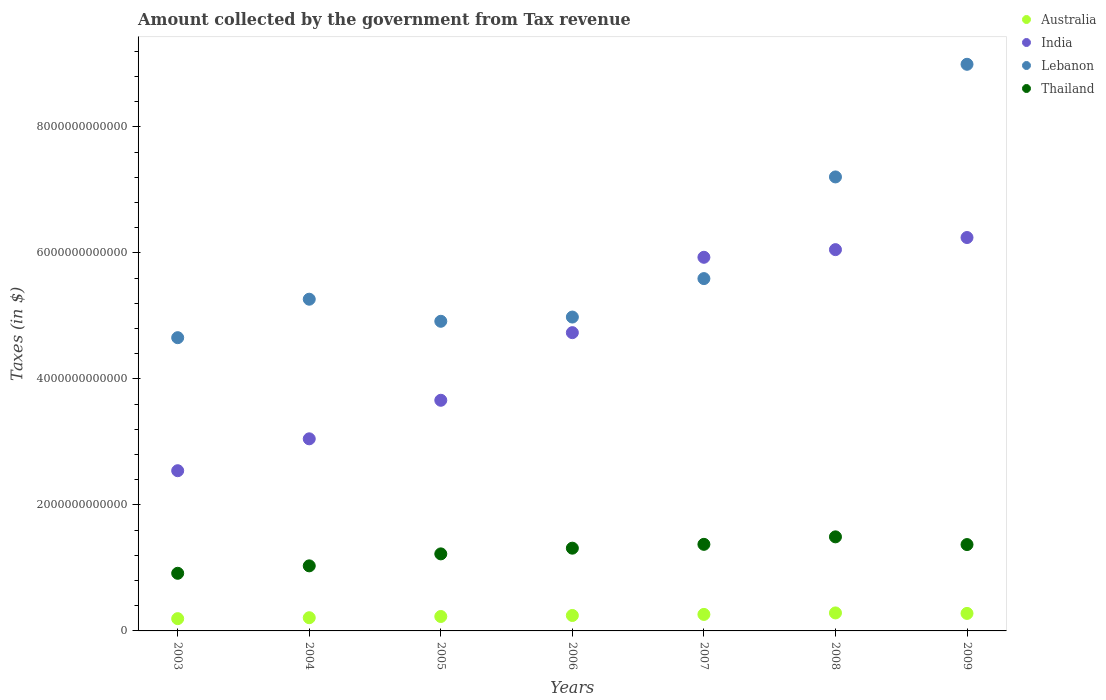How many different coloured dotlines are there?
Provide a succinct answer. 4. What is the amount collected by the government from tax revenue in Australia in 2006?
Give a very brief answer. 2.45e+11. Across all years, what is the maximum amount collected by the government from tax revenue in India?
Your answer should be very brief. 6.25e+12. Across all years, what is the minimum amount collected by the government from tax revenue in Lebanon?
Your answer should be compact. 4.66e+12. In which year was the amount collected by the government from tax revenue in Lebanon maximum?
Make the answer very short. 2009. What is the total amount collected by the government from tax revenue in Thailand in the graph?
Offer a very short reply. 8.72e+12. What is the difference between the amount collected by the government from tax revenue in Thailand in 2006 and that in 2009?
Ensure brevity in your answer.  -5.74e+1. What is the difference between the amount collected by the government from tax revenue in Australia in 2006 and the amount collected by the government from tax revenue in Lebanon in 2003?
Keep it short and to the point. -4.41e+12. What is the average amount collected by the government from tax revenue in Lebanon per year?
Offer a very short reply. 5.95e+12. In the year 2005, what is the difference between the amount collected by the government from tax revenue in India and amount collected by the government from tax revenue in Lebanon?
Give a very brief answer. -1.25e+12. In how many years, is the amount collected by the government from tax revenue in Lebanon greater than 4000000000000 $?
Your answer should be compact. 7. What is the ratio of the amount collected by the government from tax revenue in India in 2006 to that in 2007?
Your answer should be very brief. 0.8. Is the difference between the amount collected by the government from tax revenue in India in 2006 and 2007 greater than the difference between the amount collected by the government from tax revenue in Lebanon in 2006 and 2007?
Offer a very short reply. No. What is the difference between the highest and the second highest amount collected by the government from tax revenue in Australia?
Give a very brief answer. 7.66e+09. What is the difference between the highest and the lowest amount collected by the government from tax revenue in Australia?
Your answer should be compact. 9.08e+1. In how many years, is the amount collected by the government from tax revenue in India greater than the average amount collected by the government from tax revenue in India taken over all years?
Your answer should be compact. 4. Is it the case that in every year, the sum of the amount collected by the government from tax revenue in India and amount collected by the government from tax revenue in Thailand  is greater than the sum of amount collected by the government from tax revenue in Lebanon and amount collected by the government from tax revenue in Australia?
Your answer should be very brief. No. Does the amount collected by the government from tax revenue in Australia monotonically increase over the years?
Your answer should be compact. No. Is the amount collected by the government from tax revenue in Thailand strictly less than the amount collected by the government from tax revenue in Australia over the years?
Ensure brevity in your answer.  No. How many dotlines are there?
Keep it short and to the point. 4. How many years are there in the graph?
Make the answer very short. 7. What is the difference between two consecutive major ticks on the Y-axis?
Provide a short and direct response. 2.00e+12. Are the values on the major ticks of Y-axis written in scientific E-notation?
Offer a terse response. No. Does the graph contain grids?
Provide a succinct answer. No. What is the title of the graph?
Ensure brevity in your answer.  Amount collected by the government from Tax revenue. What is the label or title of the X-axis?
Make the answer very short. Years. What is the label or title of the Y-axis?
Provide a succinct answer. Taxes (in $). What is the Taxes (in $) of Australia in 2003?
Ensure brevity in your answer.  1.95e+11. What is the Taxes (in $) in India in 2003?
Your answer should be compact. 2.54e+12. What is the Taxes (in $) of Lebanon in 2003?
Give a very brief answer. 4.66e+12. What is the Taxes (in $) in Thailand in 2003?
Your response must be concise. 9.15e+11. What is the Taxes (in $) in Australia in 2004?
Provide a succinct answer. 2.10e+11. What is the Taxes (in $) in India in 2004?
Your answer should be compact. 3.05e+12. What is the Taxes (in $) of Lebanon in 2004?
Ensure brevity in your answer.  5.27e+12. What is the Taxes (in $) in Thailand in 2004?
Provide a succinct answer. 1.03e+12. What is the Taxes (in $) in Australia in 2005?
Provide a short and direct response. 2.29e+11. What is the Taxes (in $) of India in 2005?
Provide a short and direct response. 3.66e+12. What is the Taxes (in $) in Lebanon in 2005?
Give a very brief answer. 4.92e+12. What is the Taxes (in $) in Thailand in 2005?
Your answer should be very brief. 1.22e+12. What is the Taxes (in $) of Australia in 2006?
Your response must be concise. 2.45e+11. What is the Taxes (in $) of India in 2006?
Offer a very short reply. 4.74e+12. What is the Taxes (in $) of Lebanon in 2006?
Your answer should be compact. 4.98e+12. What is the Taxes (in $) in Thailand in 2006?
Provide a short and direct response. 1.31e+12. What is the Taxes (in $) of Australia in 2007?
Make the answer very short. 2.62e+11. What is the Taxes (in $) in India in 2007?
Ensure brevity in your answer.  5.93e+12. What is the Taxes (in $) in Lebanon in 2007?
Make the answer very short. 5.59e+12. What is the Taxes (in $) of Thailand in 2007?
Make the answer very short. 1.37e+12. What is the Taxes (in $) in Australia in 2008?
Offer a very short reply. 2.86e+11. What is the Taxes (in $) in India in 2008?
Your answer should be very brief. 6.05e+12. What is the Taxes (in $) in Lebanon in 2008?
Ensure brevity in your answer.  7.21e+12. What is the Taxes (in $) in Thailand in 2008?
Provide a succinct answer. 1.49e+12. What is the Taxes (in $) in Australia in 2009?
Your answer should be compact. 2.78e+11. What is the Taxes (in $) in India in 2009?
Make the answer very short. 6.25e+12. What is the Taxes (in $) of Lebanon in 2009?
Provide a succinct answer. 9.00e+12. What is the Taxes (in $) of Thailand in 2009?
Make the answer very short. 1.37e+12. Across all years, what is the maximum Taxes (in $) in Australia?
Keep it short and to the point. 2.86e+11. Across all years, what is the maximum Taxes (in $) of India?
Your response must be concise. 6.25e+12. Across all years, what is the maximum Taxes (in $) in Lebanon?
Your answer should be very brief. 9.00e+12. Across all years, what is the maximum Taxes (in $) in Thailand?
Your answer should be compact. 1.49e+12. Across all years, what is the minimum Taxes (in $) in Australia?
Offer a very short reply. 1.95e+11. Across all years, what is the minimum Taxes (in $) of India?
Provide a succinct answer. 2.54e+12. Across all years, what is the minimum Taxes (in $) of Lebanon?
Your answer should be compact. 4.66e+12. Across all years, what is the minimum Taxes (in $) of Thailand?
Give a very brief answer. 9.15e+11. What is the total Taxes (in $) of Australia in the graph?
Give a very brief answer. 1.70e+12. What is the total Taxes (in $) in India in the graph?
Offer a very short reply. 3.22e+13. What is the total Taxes (in $) in Lebanon in the graph?
Offer a very short reply. 4.16e+13. What is the total Taxes (in $) in Thailand in the graph?
Your answer should be compact. 8.72e+12. What is the difference between the Taxes (in $) of Australia in 2003 and that in 2004?
Offer a very short reply. -1.47e+1. What is the difference between the Taxes (in $) in India in 2003 and that in 2004?
Offer a very short reply. -5.06e+11. What is the difference between the Taxes (in $) of Lebanon in 2003 and that in 2004?
Your answer should be compact. -6.11e+11. What is the difference between the Taxes (in $) of Thailand in 2003 and that in 2004?
Your answer should be very brief. -1.18e+11. What is the difference between the Taxes (in $) of Australia in 2003 and that in 2005?
Give a very brief answer. -3.43e+1. What is the difference between the Taxes (in $) of India in 2003 and that in 2005?
Provide a short and direct response. -1.12e+12. What is the difference between the Taxes (in $) in Lebanon in 2003 and that in 2005?
Ensure brevity in your answer.  -2.60e+11. What is the difference between the Taxes (in $) in Thailand in 2003 and that in 2005?
Keep it short and to the point. -3.08e+11. What is the difference between the Taxes (in $) of Australia in 2003 and that in 2006?
Offer a terse response. -5.04e+1. What is the difference between the Taxes (in $) of India in 2003 and that in 2006?
Make the answer very short. -2.19e+12. What is the difference between the Taxes (in $) of Lebanon in 2003 and that in 2006?
Provide a short and direct response. -3.27e+11. What is the difference between the Taxes (in $) of Thailand in 2003 and that in 2006?
Make the answer very short. -3.99e+11. What is the difference between the Taxes (in $) in Australia in 2003 and that in 2007?
Offer a terse response. -6.72e+1. What is the difference between the Taxes (in $) in India in 2003 and that in 2007?
Offer a terse response. -3.39e+12. What is the difference between the Taxes (in $) in Lebanon in 2003 and that in 2007?
Your answer should be very brief. -9.38e+11. What is the difference between the Taxes (in $) in Thailand in 2003 and that in 2007?
Ensure brevity in your answer.  -4.60e+11. What is the difference between the Taxes (in $) of Australia in 2003 and that in 2008?
Your answer should be very brief. -9.08e+1. What is the difference between the Taxes (in $) of India in 2003 and that in 2008?
Provide a succinct answer. -3.51e+12. What is the difference between the Taxes (in $) in Lebanon in 2003 and that in 2008?
Offer a terse response. -2.55e+12. What is the difference between the Taxes (in $) in Thailand in 2003 and that in 2008?
Make the answer very short. -5.79e+11. What is the difference between the Taxes (in $) of Australia in 2003 and that in 2009?
Keep it short and to the point. -8.32e+1. What is the difference between the Taxes (in $) in India in 2003 and that in 2009?
Keep it short and to the point. -3.70e+12. What is the difference between the Taxes (in $) of Lebanon in 2003 and that in 2009?
Offer a very short reply. -4.34e+12. What is the difference between the Taxes (in $) in Thailand in 2003 and that in 2009?
Provide a succinct answer. -4.56e+11. What is the difference between the Taxes (in $) of Australia in 2004 and that in 2005?
Make the answer very short. -1.96e+1. What is the difference between the Taxes (in $) in India in 2004 and that in 2005?
Ensure brevity in your answer.  -6.12e+11. What is the difference between the Taxes (in $) in Lebanon in 2004 and that in 2005?
Your answer should be compact. 3.50e+11. What is the difference between the Taxes (in $) of Thailand in 2004 and that in 2005?
Keep it short and to the point. -1.90e+11. What is the difference between the Taxes (in $) in Australia in 2004 and that in 2006?
Your answer should be compact. -3.57e+1. What is the difference between the Taxes (in $) of India in 2004 and that in 2006?
Your response must be concise. -1.69e+12. What is the difference between the Taxes (in $) in Lebanon in 2004 and that in 2006?
Offer a very short reply. 2.83e+11. What is the difference between the Taxes (in $) in Thailand in 2004 and that in 2006?
Keep it short and to the point. -2.81e+11. What is the difference between the Taxes (in $) of Australia in 2004 and that in 2007?
Your answer should be compact. -5.24e+1. What is the difference between the Taxes (in $) of India in 2004 and that in 2007?
Your answer should be compact. -2.88e+12. What is the difference between the Taxes (in $) of Lebanon in 2004 and that in 2007?
Your answer should be very brief. -3.27e+11. What is the difference between the Taxes (in $) of Thailand in 2004 and that in 2007?
Keep it short and to the point. -3.41e+11. What is the difference between the Taxes (in $) in Australia in 2004 and that in 2008?
Give a very brief answer. -7.61e+1. What is the difference between the Taxes (in $) of India in 2004 and that in 2008?
Provide a short and direct response. -3.00e+12. What is the difference between the Taxes (in $) of Lebanon in 2004 and that in 2008?
Keep it short and to the point. -1.94e+12. What is the difference between the Taxes (in $) in Thailand in 2004 and that in 2008?
Your answer should be very brief. -4.60e+11. What is the difference between the Taxes (in $) of Australia in 2004 and that in 2009?
Offer a very short reply. -6.84e+1. What is the difference between the Taxes (in $) in India in 2004 and that in 2009?
Ensure brevity in your answer.  -3.20e+12. What is the difference between the Taxes (in $) in Lebanon in 2004 and that in 2009?
Your answer should be very brief. -3.73e+12. What is the difference between the Taxes (in $) of Thailand in 2004 and that in 2009?
Provide a short and direct response. -3.38e+11. What is the difference between the Taxes (in $) in Australia in 2005 and that in 2006?
Ensure brevity in your answer.  -1.61e+1. What is the difference between the Taxes (in $) of India in 2005 and that in 2006?
Offer a terse response. -1.07e+12. What is the difference between the Taxes (in $) of Lebanon in 2005 and that in 2006?
Your response must be concise. -6.71e+1. What is the difference between the Taxes (in $) of Thailand in 2005 and that in 2006?
Make the answer very short. -9.06e+1. What is the difference between the Taxes (in $) in Australia in 2005 and that in 2007?
Provide a succinct answer. -3.29e+1. What is the difference between the Taxes (in $) in India in 2005 and that in 2007?
Your response must be concise. -2.27e+12. What is the difference between the Taxes (in $) of Lebanon in 2005 and that in 2007?
Provide a short and direct response. -6.78e+11. What is the difference between the Taxes (in $) in Thailand in 2005 and that in 2007?
Your answer should be compact. -1.51e+11. What is the difference between the Taxes (in $) of Australia in 2005 and that in 2008?
Keep it short and to the point. -5.65e+1. What is the difference between the Taxes (in $) in India in 2005 and that in 2008?
Provide a short and direct response. -2.39e+12. What is the difference between the Taxes (in $) in Lebanon in 2005 and that in 2008?
Keep it short and to the point. -2.29e+12. What is the difference between the Taxes (in $) in Thailand in 2005 and that in 2008?
Offer a terse response. -2.70e+11. What is the difference between the Taxes (in $) in Australia in 2005 and that in 2009?
Give a very brief answer. -4.89e+1. What is the difference between the Taxes (in $) in India in 2005 and that in 2009?
Your answer should be compact. -2.58e+12. What is the difference between the Taxes (in $) in Lebanon in 2005 and that in 2009?
Ensure brevity in your answer.  -4.08e+12. What is the difference between the Taxes (in $) in Thailand in 2005 and that in 2009?
Your answer should be very brief. -1.48e+11. What is the difference between the Taxes (in $) in Australia in 2006 and that in 2007?
Give a very brief answer. -1.68e+1. What is the difference between the Taxes (in $) of India in 2006 and that in 2007?
Keep it short and to the point. -1.20e+12. What is the difference between the Taxes (in $) in Lebanon in 2006 and that in 2007?
Make the answer very short. -6.11e+11. What is the difference between the Taxes (in $) of Thailand in 2006 and that in 2007?
Offer a terse response. -6.08e+1. What is the difference between the Taxes (in $) of Australia in 2006 and that in 2008?
Provide a succinct answer. -4.04e+1. What is the difference between the Taxes (in $) of India in 2006 and that in 2008?
Your answer should be very brief. -1.32e+12. What is the difference between the Taxes (in $) of Lebanon in 2006 and that in 2008?
Offer a very short reply. -2.22e+12. What is the difference between the Taxes (in $) in Thailand in 2006 and that in 2008?
Offer a terse response. -1.80e+11. What is the difference between the Taxes (in $) in Australia in 2006 and that in 2009?
Your answer should be compact. -3.28e+1. What is the difference between the Taxes (in $) in India in 2006 and that in 2009?
Offer a very short reply. -1.51e+12. What is the difference between the Taxes (in $) of Lebanon in 2006 and that in 2009?
Provide a succinct answer. -4.01e+12. What is the difference between the Taxes (in $) in Thailand in 2006 and that in 2009?
Your response must be concise. -5.74e+1. What is the difference between the Taxes (in $) of Australia in 2007 and that in 2008?
Your response must be concise. -2.37e+1. What is the difference between the Taxes (in $) of India in 2007 and that in 2008?
Your answer should be very brief. -1.22e+11. What is the difference between the Taxes (in $) of Lebanon in 2007 and that in 2008?
Make the answer very short. -1.61e+12. What is the difference between the Taxes (in $) in Thailand in 2007 and that in 2008?
Ensure brevity in your answer.  -1.19e+11. What is the difference between the Taxes (in $) in Australia in 2007 and that in 2009?
Your response must be concise. -1.60e+1. What is the difference between the Taxes (in $) of India in 2007 and that in 2009?
Your answer should be very brief. -3.14e+11. What is the difference between the Taxes (in $) of Lebanon in 2007 and that in 2009?
Offer a very short reply. -3.40e+12. What is the difference between the Taxes (in $) in Thailand in 2007 and that in 2009?
Offer a terse response. 3.46e+09. What is the difference between the Taxes (in $) of Australia in 2008 and that in 2009?
Provide a succinct answer. 7.66e+09. What is the difference between the Taxes (in $) in India in 2008 and that in 2009?
Give a very brief answer. -1.92e+11. What is the difference between the Taxes (in $) in Lebanon in 2008 and that in 2009?
Keep it short and to the point. -1.79e+12. What is the difference between the Taxes (in $) in Thailand in 2008 and that in 2009?
Offer a very short reply. 1.22e+11. What is the difference between the Taxes (in $) of Australia in 2003 and the Taxes (in $) of India in 2004?
Provide a succinct answer. -2.85e+12. What is the difference between the Taxes (in $) of Australia in 2003 and the Taxes (in $) of Lebanon in 2004?
Your response must be concise. -5.07e+12. What is the difference between the Taxes (in $) of Australia in 2003 and the Taxes (in $) of Thailand in 2004?
Make the answer very short. -8.38e+11. What is the difference between the Taxes (in $) in India in 2003 and the Taxes (in $) in Lebanon in 2004?
Provide a short and direct response. -2.72e+12. What is the difference between the Taxes (in $) of India in 2003 and the Taxes (in $) of Thailand in 2004?
Your response must be concise. 1.51e+12. What is the difference between the Taxes (in $) of Lebanon in 2003 and the Taxes (in $) of Thailand in 2004?
Make the answer very short. 3.62e+12. What is the difference between the Taxes (in $) in Australia in 2003 and the Taxes (in $) in India in 2005?
Keep it short and to the point. -3.47e+12. What is the difference between the Taxes (in $) in Australia in 2003 and the Taxes (in $) in Lebanon in 2005?
Your answer should be very brief. -4.72e+12. What is the difference between the Taxes (in $) of Australia in 2003 and the Taxes (in $) of Thailand in 2005?
Your response must be concise. -1.03e+12. What is the difference between the Taxes (in $) in India in 2003 and the Taxes (in $) in Lebanon in 2005?
Your answer should be very brief. -2.37e+12. What is the difference between the Taxes (in $) of India in 2003 and the Taxes (in $) of Thailand in 2005?
Give a very brief answer. 1.32e+12. What is the difference between the Taxes (in $) of Lebanon in 2003 and the Taxes (in $) of Thailand in 2005?
Your answer should be very brief. 3.43e+12. What is the difference between the Taxes (in $) in Australia in 2003 and the Taxes (in $) in India in 2006?
Ensure brevity in your answer.  -4.54e+12. What is the difference between the Taxes (in $) in Australia in 2003 and the Taxes (in $) in Lebanon in 2006?
Keep it short and to the point. -4.79e+12. What is the difference between the Taxes (in $) in Australia in 2003 and the Taxes (in $) in Thailand in 2006?
Provide a succinct answer. -1.12e+12. What is the difference between the Taxes (in $) in India in 2003 and the Taxes (in $) in Lebanon in 2006?
Offer a very short reply. -2.44e+12. What is the difference between the Taxes (in $) in India in 2003 and the Taxes (in $) in Thailand in 2006?
Give a very brief answer. 1.23e+12. What is the difference between the Taxes (in $) in Lebanon in 2003 and the Taxes (in $) in Thailand in 2006?
Provide a succinct answer. 3.34e+12. What is the difference between the Taxes (in $) of Australia in 2003 and the Taxes (in $) of India in 2007?
Provide a succinct answer. -5.74e+12. What is the difference between the Taxes (in $) of Australia in 2003 and the Taxes (in $) of Lebanon in 2007?
Give a very brief answer. -5.40e+12. What is the difference between the Taxes (in $) of Australia in 2003 and the Taxes (in $) of Thailand in 2007?
Ensure brevity in your answer.  -1.18e+12. What is the difference between the Taxes (in $) in India in 2003 and the Taxes (in $) in Lebanon in 2007?
Keep it short and to the point. -3.05e+12. What is the difference between the Taxes (in $) of India in 2003 and the Taxes (in $) of Thailand in 2007?
Your answer should be very brief. 1.17e+12. What is the difference between the Taxes (in $) in Lebanon in 2003 and the Taxes (in $) in Thailand in 2007?
Offer a terse response. 3.28e+12. What is the difference between the Taxes (in $) of Australia in 2003 and the Taxes (in $) of India in 2008?
Ensure brevity in your answer.  -5.86e+12. What is the difference between the Taxes (in $) in Australia in 2003 and the Taxes (in $) in Lebanon in 2008?
Offer a very short reply. -7.01e+12. What is the difference between the Taxes (in $) of Australia in 2003 and the Taxes (in $) of Thailand in 2008?
Give a very brief answer. -1.30e+12. What is the difference between the Taxes (in $) in India in 2003 and the Taxes (in $) in Lebanon in 2008?
Your answer should be very brief. -4.66e+12. What is the difference between the Taxes (in $) of India in 2003 and the Taxes (in $) of Thailand in 2008?
Your response must be concise. 1.05e+12. What is the difference between the Taxes (in $) in Lebanon in 2003 and the Taxes (in $) in Thailand in 2008?
Offer a very short reply. 3.16e+12. What is the difference between the Taxes (in $) in Australia in 2003 and the Taxes (in $) in India in 2009?
Keep it short and to the point. -6.05e+12. What is the difference between the Taxes (in $) in Australia in 2003 and the Taxes (in $) in Lebanon in 2009?
Provide a succinct answer. -8.80e+12. What is the difference between the Taxes (in $) in Australia in 2003 and the Taxes (in $) in Thailand in 2009?
Your response must be concise. -1.18e+12. What is the difference between the Taxes (in $) of India in 2003 and the Taxes (in $) of Lebanon in 2009?
Your answer should be very brief. -6.45e+12. What is the difference between the Taxes (in $) of India in 2003 and the Taxes (in $) of Thailand in 2009?
Keep it short and to the point. 1.17e+12. What is the difference between the Taxes (in $) of Lebanon in 2003 and the Taxes (in $) of Thailand in 2009?
Your response must be concise. 3.28e+12. What is the difference between the Taxes (in $) of Australia in 2004 and the Taxes (in $) of India in 2005?
Keep it short and to the point. -3.45e+12. What is the difference between the Taxes (in $) in Australia in 2004 and the Taxes (in $) in Lebanon in 2005?
Provide a short and direct response. -4.71e+12. What is the difference between the Taxes (in $) in Australia in 2004 and the Taxes (in $) in Thailand in 2005?
Your answer should be very brief. -1.01e+12. What is the difference between the Taxes (in $) of India in 2004 and the Taxes (in $) of Lebanon in 2005?
Your answer should be compact. -1.87e+12. What is the difference between the Taxes (in $) in India in 2004 and the Taxes (in $) in Thailand in 2005?
Offer a terse response. 1.83e+12. What is the difference between the Taxes (in $) of Lebanon in 2004 and the Taxes (in $) of Thailand in 2005?
Keep it short and to the point. 4.04e+12. What is the difference between the Taxes (in $) of Australia in 2004 and the Taxes (in $) of India in 2006?
Ensure brevity in your answer.  -4.53e+12. What is the difference between the Taxes (in $) of Australia in 2004 and the Taxes (in $) of Lebanon in 2006?
Offer a very short reply. -4.77e+12. What is the difference between the Taxes (in $) in Australia in 2004 and the Taxes (in $) in Thailand in 2006?
Your response must be concise. -1.10e+12. What is the difference between the Taxes (in $) of India in 2004 and the Taxes (in $) of Lebanon in 2006?
Your answer should be compact. -1.93e+12. What is the difference between the Taxes (in $) in India in 2004 and the Taxes (in $) in Thailand in 2006?
Your answer should be compact. 1.74e+12. What is the difference between the Taxes (in $) in Lebanon in 2004 and the Taxes (in $) in Thailand in 2006?
Provide a succinct answer. 3.95e+12. What is the difference between the Taxes (in $) of Australia in 2004 and the Taxes (in $) of India in 2007?
Offer a very short reply. -5.72e+12. What is the difference between the Taxes (in $) of Australia in 2004 and the Taxes (in $) of Lebanon in 2007?
Ensure brevity in your answer.  -5.38e+12. What is the difference between the Taxes (in $) of Australia in 2004 and the Taxes (in $) of Thailand in 2007?
Offer a very short reply. -1.16e+12. What is the difference between the Taxes (in $) in India in 2004 and the Taxes (in $) in Lebanon in 2007?
Your response must be concise. -2.54e+12. What is the difference between the Taxes (in $) in India in 2004 and the Taxes (in $) in Thailand in 2007?
Offer a very short reply. 1.68e+12. What is the difference between the Taxes (in $) in Lebanon in 2004 and the Taxes (in $) in Thailand in 2007?
Your response must be concise. 3.89e+12. What is the difference between the Taxes (in $) in Australia in 2004 and the Taxes (in $) in India in 2008?
Make the answer very short. -5.84e+12. What is the difference between the Taxes (in $) in Australia in 2004 and the Taxes (in $) in Lebanon in 2008?
Offer a terse response. -7.00e+12. What is the difference between the Taxes (in $) in Australia in 2004 and the Taxes (in $) in Thailand in 2008?
Ensure brevity in your answer.  -1.28e+12. What is the difference between the Taxes (in $) in India in 2004 and the Taxes (in $) in Lebanon in 2008?
Offer a very short reply. -4.16e+12. What is the difference between the Taxes (in $) of India in 2004 and the Taxes (in $) of Thailand in 2008?
Keep it short and to the point. 1.56e+12. What is the difference between the Taxes (in $) in Lebanon in 2004 and the Taxes (in $) in Thailand in 2008?
Your response must be concise. 3.77e+12. What is the difference between the Taxes (in $) in Australia in 2004 and the Taxes (in $) in India in 2009?
Provide a short and direct response. -6.04e+12. What is the difference between the Taxes (in $) of Australia in 2004 and the Taxes (in $) of Lebanon in 2009?
Offer a terse response. -8.79e+12. What is the difference between the Taxes (in $) in Australia in 2004 and the Taxes (in $) in Thailand in 2009?
Make the answer very short. -1.16e+12. What is the difference between the Taxes (in $) in India in 2004 and the Taxes (in $) in Lebanon in 2009?
Offer a very short reply. -5.95e+12. What is the difference between the Taxes (in $) of India in 2004 and the Taxes (in $) of Thailand in 2009?
Your answer should be very brief. 1.68e+12. What is the difference between the Taxes (in $) of Lebanon in 2004 and the Taxes (in $) of Thailand in 2009?
Your answer should be compact. 3.90e+12. What is the difference between the Taxes (in $) in Australia in 2005 and the Taxes (in $) in India in 2006?
Your response must be concise. -4.51e+12. What is the difference between the Taxes (in $) of Australia in 2005 and the Taxes (in $) of Lebanon in 2006?
Give a very brief answer. -4.75e+12. What is the difference between the Taxes (in $) in Australia in 2005 and the Taxes (in $) in Thailand in 2006?
Provide a succinct answer. -1.08e+12. What is the difference between the Taxes (in $) in India in 2005 and the Taxes (in $) in Lebanon in 2006?
Provide a short and direct response. -1.32e+12. What is the difference between the Taxes (in $) in India in 2005 and the Taxes (in $) in Thailand in 2006?
Offer a terse response. 2.35e+12. What is the difference between the Taxes (in $) of Lebanon in 2005 and the Taxes (in $) of Thailand in 2006?
Keep it short and to the point. 3.60e+12. What is the difference between the Taxes (in $) in Australia in 2005 and the Taxes (in $) in India in 2007?
Provide a succinct answer. -5.70e+12. What is the difference between the Taxes (in $) in Australia in 2005 and the Taxes (in $) in Lebanon in 2007?
Keep it short and to the point. -5.36e+12. What is the difference between the Taxes (in $) of Australia in 2005 and the Taxes (in $) of Thailand in 2007?
Give a very brief answer. -1.15e+12. What is the difference between the Taxes (in $) in India in 2005 and the Taxes (in $) in Lebanon in 2007?
Ensure brevity in your answer.  -1.93e+12. What is the difference between the Taxes (in $) of India in 2005 and the Taxes (in $) of Thailand in 2007?
Ensure brevity in your answer.  2.29e+12. What is the difference between the Taxes (in $) of Lebanon in 2005 and the Taxes (in $) of Thailand in 2007?
Ensure brevity in your answer.  3.54e+12. What is the difference between the Taxes (in $) in Australia in 2005 and the Taxes (in $) in India in 2008?
Keep it short and to the point. -5.82e+12. What is the difference between the Taxes (in $) of Australia in 2005 and the Taxes (in $) of Lebanon in 2008?
Your response must be concise. -6.98e+12. What is the difference between the Taxes (in $) in Australia in 2005 and the Taxes (in $) in Thailand in 2008?
Your response must be concise. -1.26e+12. What is the difference between the Taxes (in $) in India in 2005 and the Taxes (in $) in Lebanon in 2008?
Keep it short and to the point. -3.55e+12. What is the difference between the Taxes (in $) of India in 2005 and the Taxes (in $) of Thailand in 2008?
Give a very brief answer. 2.17e+12. What is the difference between the Taxes (in $) of Lebanon in 2005 and the Taxes (in $) of Thailand in 2008?
Offer a very short reply. 3.42e+12. What is the difference between the Taxes (in $) of Australia in 2005 and the Taxes (in $) of India in 2009?
Keep it short and to the point. -6.02e+12. What is the difference between the Taxes (in $) of Australia in 2005 and the Taxes (in $) of Lebanon in 2009?
Provide a succinct answer. -8.77e+12. What is the difference between the Taxes (in $) of Australia in 2005 and the Taxes (in $) of Thailand in 2009?
Your answer should be compact. -1.14e+12. What is the difference between the Taxes (in $) in India in 2005 and the Taxes (in $) in Lebanon in 2009?
Your answer should be very brief. -5.33e+12. What is the difference between the Taxes (in $) of India in 2005 and the Taxes (in $) of Thailand in 2009?
Provide a succinct answer. 2.29e+12. What is the difference between the Taxes (in $) in Lebanon in 2005 and the Taxes (in $) in Thailand in 2009?
Offer a very short reply. 3.54e+12. What is the difference between the Taxes (in $) in Australia in 2006 and the Taxes (in $) in India in 2007?
Your answer should be very brief. -5.69e+12. What is the difference between the Taxes (in $) in Australia in 2006 and the Taxes (in $) in Lebanon in 2007?
Your answer should be very brief. -5.35e+12. What is the difference between the Taxes (in $) of Australia in 2006 and the Taxes (in $) of Thailand in 2007?
Provide a short and direct response. -1.13e+12. What is the difference between the Taxes (in $) in India in 2006 and the Taxes (in $) in Lebanon in 2007?
Give a very brief answer. -8.58e+11. What is the difference between the Taxes (in $) of India in 2006 and the Taxes (in $) of Thailand in 2007?
Provide a short and direct response. 3.36e+12. What is the difference between the Taxes (in $) of Lebanon in 2006 and the Taxes (in $) of Thailand in 2007?
Give a very brief answer. 3.61e+12. What is the difference between the Taxes (in $) of Australia in 2006 and the Taxes (in $) of India in 2008?
Give a very brief answer. -5.81e+12. What is the difference between the Taxes (in $) of Australia in 2006 and the Taxes (in $) of Lebanon in 2008?
Ensure brevity in your answer.  -6.96e+12. What is the difference between the Taxes (in $) of Australia in 2006 and the Taxes (in $) of Thailand in 2008?
Your answer should be compact. -1.25e+12. What is the difference between the Taxes (in $) in India in 2006 and the Taxes (in $) in Lebanon in 2008?
Your answer should be very brief. -2.47e+12. What is the difference between the Taxes (in $) in India in 2006 and the Taxes (in $) in Thailand in 2008?
Keep it short and to the point. 3.24e+12. What is the difference between the Taxes (in $) in Lebanon in 2006 and the Taxes (in $) in Thailand in 2008?
Your answer should be compact. 3.49e+12. What is the difference between the Taxes (in $) of Australia in 2006 and the Taxes (in $) of India in 2009?
Offer a terse response. -6.00e+12. What is the difference between the Taxes (in $) in Australia in 2006 and the Taxes (in $) in Lebanon in 2009?
Provide a succinct answer. -8.75e+12. What is the difference between the Taxes (in $) in Australia in 2006 and the Taxes (in $) in Thailand in 2009?
Provide a succinct answer. -1.13e+12. What is the difference between the Taxes (in $) in India in 2006 and the Taxes (in $) in Lebanon in 2009?
Keep it short and to the point. -4.26e+12. What is the difference between the Taxes (in $) of India in 2006 and the Taxes (in $) of Thailand in 2009?
Your answer should be compact. 3.36e+12. What is the difference between the Taxes (in $) in Lebanon in 2006 and the Taxes (in $) in Thailand in 2009?
Ensure brevity in your answer.  3.61e+12. What is the difference between the Taxes (in $) of Australia in 2007 and the Taxes (in $) of India in 2008?
Your answer should be compact. -5.79e+12. What is the difference between the Taxes (in $) in Australia in 2007 and the Taxes (in $) in Lebanon in 2008?
Offer a very short reply. -6.95e+12. What is the difference between the Taxes (in $) in Australia in 2007 and the Taxes (in $) in Thailand in 2008?
Offer a terse response. -1.23e+12. What is the difference between the Taxes (in $) of India in 2007 and the Taxes (in $) of Lebanon in 2008?
Offer a very short reply. -1.28e+12. What is the difference between the Taxes (in $) in India in 2007 and the Taxes (in $) in Thailand in 2008?
Give a very brief answer. 4.44e+12. What is the difference between the Taxes (in $) of Lebanon in 2007 and the Taxes (in $) of Thailand in 2008?
Offer a terse response. 4.10e+12. What is the difference between the Taxes (in $) of Australia in 2007 and the Taxes (in $) of India in 2009?
Your answer should be very brief. -5.98e+12. What is the difference between the Taxes (in $) in Australia in 2007 and the Taxes (in $) in Lebanon in 2009?
Ensure brevity in your answer.  -8.73e+12. What is the difference between the Taxes (in $) of Australia in 2007 and the Taxes (in $) of Thailand in 2009?
Provide a short and direct response. -1.11e+12. What is the difference between the Taxes (in $) in India in 2007 and the Taxes (in $) in Lebanon in 2009?
Your answer should be compact. -3.06e+12. What is the difference between the Taxes (in $) of India in 2007 and the Taxes (in $) of Thailand in 2009?
Your response must be concise. 4.56e+12. What is the difference between the Taxes (in $) in Lebanon in 2007 and the Taxes (in $) in Thailand in 2009?
Provide a short and direct response. 4.22e+12. What is the difference between the Taxes (in $) of Australia in 2008 and the Taxes (in $) of India in 2009?
Your answer should be compact. -5.96e+12. What is the difference between the Taxes (in $) in Australia in 2008 and the Taxes (in $) in Lebanon in 2009?
Provide a succinct answer. -8.71e+12. What is the difference between the Taxes (in $) of Australia in 2008 and the Taxes (in $) of Thailand in 2009?
Offer a terse response. -1.09e+12. What is the difference between the Taxes (in $) of India in 2008 and the Taxes (in $) of Lebanon in 2009?
Your answer should be very brief. -2.94e+12. What is the difference between the Taxes (in $) in India in 2008 and the Taxes (in $) in Thailand in 2009?
Offer a very short reply. 4.68e+12. What is the difference between the Taxes (in $) in Lebanon in 2008 and the Taxes (in $) in Thailand in 2009?
Your answer should be compact. 5.84e+12. What is the average Taxes (in $) of Australia per year?
Offer a very short reply. 2.43e+11. What is the average Taxes (in $) of India per year?
Your answer should be compact. 4.60e+12. What is the average Taxes (in $) of Lebanon per year?
Offer a very short reply. 5.95e+12. What is the average Taxes (in $) of Thailand per year?
Offer a very short reply. 1.25e+12. In the year 2003, what is the difference between the Taxes (in $) in Australia and Taxes (in $) in India?
Keep it short and to the point. -2.35e+12. In the year 2003, what is the difference between the Taxes (in $) in Australia and Taxes (in $) in Lebanon?
Provide a succinct answer. -4.46e+12. In the year 2003, what is the difference between the Taxes (in $) of Australia and Taxes (in $) of Thailand?
Keep it short and to the point. -7.20e+11. In the year 2003, what is the difference between the Taxes (in $) in India and Taxes (in $) in Lebanon?
Offer a terse response. -2.11e+12. In the year 2003, what is the difference between the Taxes (in $) in India and Taxes (in $) in Thailand?
Your answer should be very brief. 1.63e+12. In the year 2003, what is the difference between the Taxes (in $) in Lebanon and Taxes (in $) in Thailand?
Your answer should be very brief. 3.74e+12. In the year 2004, what is the difference between the Taxes (in $) in Australia and Taxes (in $) in India?
Offer a very short reply. -2.84e+12. In the year 2004, what is the difference between the Taxes (in $) of Australia and Taxes (in $) of Lebanon?
Your answer should be very brief. -5.06e+12. In the year 2004, what is the difference between the Taxes (in $) of Australia and Taxes (in $) of Thailand?
Offer a terse response. -8.23e+11. In the year 2004, what is the difference between the Taxes (in $) in India and Taxes (in $) in Lebanon?
Make the answer very short. -2.22e+12. In the year 2004, what is the difference between the Taxes (in $) of India and Taxes (in $) of Thailand?
Keep it short and to the point. 2.02e+12. In the year 2004, what is the difference between the Taxes (in $) of Lebanon and Taxes (in $) of Thailand?
Your response must be concise. 4.23e+12. In the year 2005, what is the difference between the Taxes (in $) of Australia and Taxes (in $) of India?
Make the answer very short. -3.43e+12. In the year 2005, what is the difference between the Taxes (in $) of Australia and Taxes (in $) of Lebanon?
Provide a succinct answer. -4.69e+12. In the year 2005, what is the difference between the Taxes (in $) of Australia and Taxes (in $) of Thailand?
Provide a succinct answer. -9.94e+11. In the year 2005, what is the difference between the Taxes (in $) in India and Taxes (in $) in Lebanon?
Provide a short and direct response. -1.25e+12. In the year 2005, what is the difference between the Taxes (in $) of India and Taxes (in $) of Thailand?
Your answer should be compact. 2.44e+12. In the year 2005, what is the difference between the Taxes (in $) in Lebanon and Taxes (in $) in Thailand?
Your answer should be compact. 3.69e+12. In the year 2006, what is the difference between the Taxes (in $) in Australia and Taxes (in $) in India?
Offer a very short reply. -4.49e+12. In the year 2006, what is the difference between the Taxes (in $) of Australia and Taxes (in $) of Lebanon?
Make the answer very short. -4.74e+12. In the year 2006, what is the difference between the Taxes (in $) in Australia and Taxes (in $) in Thailand?
Provide a short and direct response. -1.07e+12. In the year 2006, what is the difference between the Taxes (in $) of India and Taxes (in $) of Lebanon?
Provide a short and direct response. -2.48e+11. In the year 2006, what is the difference between the Taxes (in $) in India and Taxes (in $) in Thailand?
Your answer should be compact. 3.42e+12. In the year 2006, what is the difference between the Taxes (in $) of Lebanon and Taxes (in $) of Thailand?
Your response must be concise. 3.67e+12. In the year 2007, what is the difference between the Taxes (in $) of Australia and Taxes (in $) of India?
Offer a terse response. -5.67e+12. In the year 2007, what is the difference between the Taxes (in $) of Australia and Taxes (in $) of Lebanon?
Provide a succinct answer. -5.33e+12. In the year 2007, what is the difference between the Taxes (in $) of Australia and Taxes (in $) of Thailand?
Give a very brief answer. -1.11e+12. In the year 2007, what is the difference between the Taxes (in $) of India and Taxes (in $) of Lebanon?
Offer a very short reply. 3.38e+11. In the year 2007, what is the difference between the Taxes (in $) of India and Taxes (in $) of Thailand?
Your answer should be compact. 4.56e+12. In the year 2007, what is the difference between the Taxes (in $) in Lebanon and Taxes (in $) in Thailand?
Keep it short and to the point. 4.22e+12. In the year 2008, what is the difference between the Taxes (in $) in Australia and Taxes (in $) in India?
Ensure brevity in your answer.  -5.77e+12. In the year 2008, what is the difference between the Taxes (in $) of Australia and Taxes (in $) of Lebanon?
Offer a very short reply. -6.92e+12. In the year 2008, what is the difference between the Taxes (in $) in Australia and Taxes (in $) in Thailand?
Offer a terse response. -1.21e+12. In the year 2008, what is the difference between the Taxes (in $) of India and Taxes (in $) of Lebanon?
Provide a succinct answer. -1.15e+12. In the year 2008, what is the difference between the Taxes (in $) in India and Taxes (in $) in Thailand?
Offer a terse response. 4.56e+12. In the year 2008, what is the difference between the Taxes (in $) of Lebanon and Taxes (in $) of Thailand?
Give a very brief answer. 5.71e+12. In the year 2009, what is the difference between the Taxes (in $) of Australia and Taxes (in $) of India?
Your answer should be very brief. -5.97e+12. In the year 2009, what is the difference between the Taxes (in $) in Australia and Taxes (in $) in Lebanon?
Provide a succinct answer. -8.72e+12. In the year 2009, what is the difference between the Taxes (in $) of Australia and Taxes (in $) of Thailand?
Your answer should be very brief. -1.09e+12. In the year 2009, what is the difference between the Taxes (in $) in India and Taxes (in $) in Lebanon?
Keep it short and to the point. -2.75e+12. In the year 2009, what is the difference between the Taxes (in $) of India and Taxes (in $) of Thailand?
Keep it short and to the point. 4.87e+12. In the year 2009, what is the difference between the Taxes (in $) of Lebanon and Taxes (in $) of Thailand?
Ensure brevity in your answer.  7.62e+12. What is the ratio of the Taxes (in $) of Australia in 2003 to that in 2004?
Your response must be concise. 0.93. What is the ratio of the Taxes (in $) of India in 2003 to that in 2004?
Your response must be concise. 0.83. What is the ratio of the Taxes (in $) in Lebanon in 2003 to that in 2004?
Offer a terse response. 0.88. What is the ratio of the Taxes (in $) of Thailand in 2003 to that in 2004?
Offer a very short reply. 0.89. What is the ratio of the Taxes (in $) of Australia in 2003 to that in 2005?
Your answer should be very brief. 0.85. What is the ratio of the Taxes (in $) in India in 2003 to that in 2005?
Make the answer very short. 0.69. What is the ratio of the Taxes (in $) in Lebanon in 2003 to that in 2005?
Offer a terse response. 0.95. What is the ratio of the Taxes (in $) in Thailand in 2003 to that in 2005?
Make the answer very short. 0.75. What is the ratio of the Taxes (in $) of Australia in 2003 to that in 2006?
Make the answer very short. 0.79. What is the ratio of the Taxes (in $) in India in 2003 to that in 2006?
Offer a very short reply. 0.54. What is the ratio of the Taxes (in $) in Lebanon in 2003 to that in 2006?
Your answer should be very brief. 0.93. What is the ratio of the Taxes (in $) in Thailand in 2003 to that in 2006?
Ensure brevity in your answer.  0.7. What is the ratio of the Taxes (in $) in Australia in 2003 to that in 2007?
Provide a succinct answer. 0.74. What is the ratio of the Taxes (in $) of India in 2003 to that in 2007?
Give a very brief answer. 0.43. What is the ratio of the Taxes (in $) of Lebanon in 2003 to that in 2007?
Your answer should be compact. 0.83. What is the ratio of the Taxes (in $) in Thailand in 2003 to that in 2007?
Provide a short and direct response. 0.67. What is the ratio of the Taxes (in $) in Australia in 2003 to that in 2008?
Keep it short and to the point. 0.68. What is the ratio of the Taxes (in $) of India in 2003 to that in 2008?
Your response must be concise. 0.42. What is the ratio of the Taxes (in $) in Lebanon in 2003 to that in 2008?
Provide a succinct answer. 0.65. What is the ratio of the Taxes (in $) in Thailand in 2003 to that in 2008?
Provide a short and direct response. 0.61. What is the ratio of the Taxes (in $) of Australia in 2003 to that in 2009?
Provide a short and direct response. 0.7. What is the ratio of the Taxes (in $) in India in 2003 to that in 2009?
Provide a succinct answer. 0.41. What is the ratio of the Taxes (in $) in Lebanon in 2003 to that in 2009?
Provide a short and direct response. 0.52. What is the ratio of the Taxes (in $) of Thailand in 2003 to that in 2009?
Ensure brevity in your answer.  0.67. What is the ratio of the Taxes (in $) in Australia in 2004 to that in 2005?
Give a very brief answer. 0.91. What is the ratio of the Taxes (in $) in India in 2004 to that in 2005?
Provide a short and direct response. 0.83. What is the ratio of the Taxes (in $) of Lebanon in 2004 to that in 2005?
Offer a terse response. 1.07. What is the ratio of the Taxes (in $) of Thailand in 2004 to that in 2005?
Keep it short and to the point. 0.84. What is the ratio of the Taxes (in $) in Australia in 2004 to that in 2006?
Ensure brevity in your answer.  0.85. What is the ratio of the Taxes (in $) of India in 2004 to that in 2006?
Offer a terse response. 0.64. What is the ratio of the Taxes (in $) in Lebanon in 2004 to that in 2006?
Keep it short and to the point. 1.06. What is the ratio of the Taxes (in $) of Thailand in 2004 to that in 2006?
Offer a very short reply. 0.79. What is the ratio of the Taxes (in $) of Australia in 2004 to that in 2007?
Offer a very short reply. 0.8. What is the ratio of the Taxes (in $) of India in 2004 to that in 2007?
Your answer should be very brief. 0.51. What is the ratio of the Taxes (in $) in Lebanon in 2004 to that in 2007?
Your answer should be compact. 0.94. What is the ratio of the Taxes (in $) of Thailand in 2004 to that in 2007?
Ensure brevity in your answer.  0.75. What is the ratio of the Taxes (in $) in Australia in 2004 to that in 2008?
Give a very brief answer. 0.73. What is the ratio of the Taxes (in $) of India in 2004 to that in 2008?
Make the answer very short. 0.5. What is the ratio of the Taxes (in $) of Lebanon in 2004 to that in 2008?
Provide a succinct answer. 0.73. What is the ratio of the Taxes (in $) of Thailand in 2004 to that in 2008?
Make the answer very short. 0.69. What is the ratio of the Taxes (in $) of Australia in 2004 to that in 2009?
Your response must be concise. 0.75. What is the ratio of the Taxes (in $) in India in 2004 to that in 2009?
Your response must be concise. 0.49. What is the ratio of the Taxes (in $) in Lebanon in 2004 to that in 2009?
Provide a succinct answer. 0.59. What is the ratio of the Taxes (in $) in Thailand in 2004 to that in 2009?
Your answer should be compact. 0.75. What is the ratio of the Taxes (in $) of Australia in 2005 to that in 2006?
Your answer should be compact. 0.93. What is the ratio of the Taxes (in $) of India in 2005 to that in 2006?
Give a very brief answer. 0.77. What is the ratio of the Taxes (in $) in Lebanon in 2005 to that in 2006?
Offer a very short reply. 0.99. What is the ratio of the Taxes (in $) of Thailand in 2005 to that in 2006?
Offer a terse response. 0.93. What is the ratio of the Taxes (in $) in Australia in 2005 to that in 2007?
Your answer should be compact. 0.87. What is the ratio of the Taxes (in $) in India in 2005 to that in 2007?
Provide a short and direct response. 0.62. What is the ratio of the Taxes (in $) in Lebanon in 2005 to that in 2007?
Make the answer very short. 0.88. What is the ratio of the Taxes (in $) of Thailand in 2005 to that in 2007?
Provide a succinct answer. 0.89. What is the ratio of the Taxes (in $) in Australia in 2005 to that in 2008?
Offer a very short reply. 0.8. What is the ratio of the Taxes (in $) in India in 2005 to that in 2008?
Your answer should be compact. 0.6. What is the ratio of the Taxes (in $) of Lebanon in 2005 to that in 2008?
Give a very brief answer. 0.68. What is the ratio of the Taxes (in $) of Thailand in 2005 to that in 2008?
Provide a succinct answer. 0.82. What is the ratio of the Taxes (in $) of Australia in 2005 to that in 2009?
Ensure brevity in your answer.  0.82. What is the ratio of the Taxes (in $) of India in 2005 to that in 2009?
Offer a terse response. 0.59. What is the ratio of the Taxes (in $) in Lebanon in 2005 to that in 2009?
Provide a short and direct response. 0.55. What is the ratio of the Taxes (in $) of Thailand in 2005 to that in 2009?
Keep it short and to the point. 0.89. What is the ratio of the Taxes (in $) of Australia in 2006 to that in 2007?
Ensure brevity in your answer.  0.94. What is the ratio of the Taxes (in $) of India in 2006 to that in 2007?
Provide a succinct answer. 0.8. What is the ratio of the Taxes (in $) in Lebanon in 2006 to that in 2007?
Ensure brevity in your answer.  0.89. What is the ratio of the Taxes (in $) of Thailand in 2006 to that in 2007?
Your answer should be compact. 0.96. What is the ratio of the Taxes (in $) in Australia in 2006 to that in 2008?
Offer a very short reply. 0.86. What is the ratio of the Taxes (in $) of India in 2006 to that in 2008?
Provide a short and direct response. 0.78. What is the ratio of the Taxes (in $) of Lebanon in 2006 to that in 2008?
Provide a short and direct response. 0.69. What is the ratio of the Taxes (in $) of Thailand in 2006 to that in 2008?
Keep it short and to the point. 0.88. What is the ratio of the Taxes (in $) of Australia in 2006 to that in 2009?
Give a very brief answer. 0.88. What is the ratio of the Taxes (in $) in India in 2006 to that in 2009?
Your answer should be compact. 0.76. What is the ratio of the Taxes (in $) of Lebanon in 2006 to that in 2009?
Your answer should be compact. 0.55. What is the ratio of the Taxes (in $) in Thailand in 2006 to that in 2009?
Offer a terse response. 0.96. What is the ratio of the Taxes (in $) in Australia in 2007 to that in 2008?
Your response must be concise. 0.92. What is the ratio of the Taxes (in $) in India in 2007 to that in 2008?
Your response must be concise. 0.98. What is the ratio of the Taxes (in $) of Lebanon in 2007 to that in 2008?
Offer a terse response. 0.78. What is the ratio of the Taxes (in $) of Thailand in 2007 to that in 2008?
Keep it short and to the point. 0.92. What is the ratio of the Taxes (in $) in Australia in 2007 to that in 2009?
Provide a succinct answer. 0.94. What is the ratio of the Taxes (in $) in India in 2007 to that in 2009?
Give a very brief answer. 0.95. What is the ratio of the Taxes (in $) of Lebanon in 2007 to that in 2009?
Offer a terse response. 0.62. What is the ratio of the Taxes (in $) of Thailand in 2007 to that in 2009?
Your response must be concise. 1. What is the ratio of the Taxes (in $) of Australia in 2008 to that in 2009?
Provide a succinct answer. 1.03. What is the ratio of the Taxes (in $) of India in 2008 to that in 2009?
Keep it short and to the point. 0.97. What is the ratio of the Taxes (in $) of Lebanon in 2008 to that in 2009?
Give a very brief answer. 0.8. What is the ratio of the Taxes (in $) in Thailand in 2008 to that in 2009?
Provide a short and direct response. 1.09. What is the difference between the highest and the second highest Taxes (in $) in Australia?
Ensure brevity in your answer.  7.66e+09. What is the difference between the highest and the second highest Taxes (in $) in India?
Your answer should be very brief. 1.92e+11. What is the difference between the highest and the second highest Taxes (in $) in Lebanon?
Make the answer very short. 1.79e+12. What is the difference between the highest and the second highest Taxes (in $) of Thailand?
Keep it short and to the point. 1.19e+11. What is the difference between the highest and the lowest Taxes (in $) of Australia?
Provide a succinct answer. 9.08e+1. What is the difference between the highest and the lowest Taxes (in $) in India?
Keep it short and to the point. 3.70e+12. What is the difference between the highest and the lowest Taxes (in $) of Lebanon?
Give a very brief answer. 4.34e+12. What is the difference between the highest and the lowest Taxes (in $) in Thailand?
Your response must be concise. 5.79e+11. 